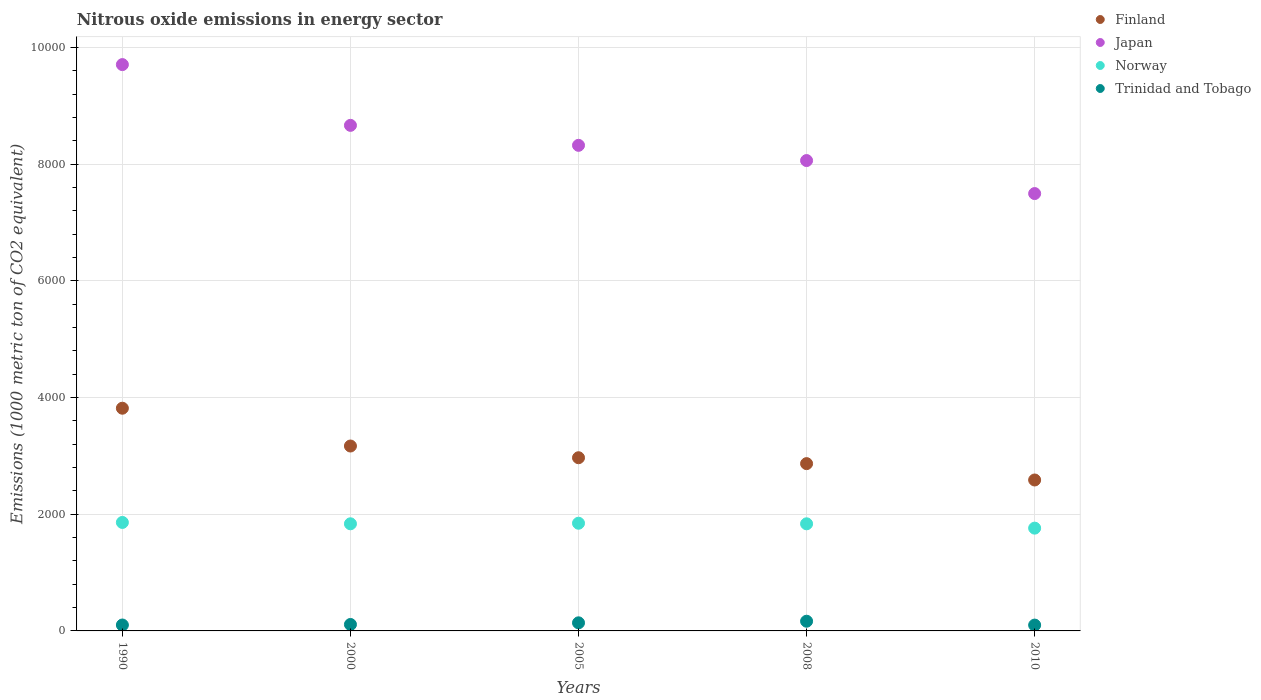Is the number of dotlines equal to the number of legend labels?
Provide a succinct answer. Yes. What is the amount of nitrous oxide emitted in Norway in 2010?
Your answer should be very brief. 1762.1. Across all years, what is the maximum amount of nitrous oxide emitted in Trinidad and Tobago?
Your answer should be compact. 166.3. Across all years, what is the minimum amount of nitrous oxide emitted in Trinidad and Tobago?
Your answer should be very brief. 100.1. In which year was the amount of nitrous oxide emitted in Trinidad and Tobago maximum?
Make the answer very short. 2008. In which year was the amount of nitrous oxide emitted in Trinidad and Tobago minimum?
Provide a short and direct response. 2010. What is the total amount of nitrous oxide emitted in Trinidad and Tobago in the graph?
Your response must be concise. 617. What is the difference between the amount of nitrous oxide emitted in Trinidad and Tobago in 1990 and that in 2010?
Keep it short and to the point. 1.2. What is the difference between the amount of nitrous oxide emitted in Finland in 2000 and the amount of nitrous oxide emitted in Trinidad and Tobago in 2008?
Offer a terse response. 3003.6. What is the average amount of nitrous oxide emitted in Norway per year?
Provide a short and direct response. 1828.16. In the year 2010, what is the difference between the amount of nitrous oxide emitted in Japan and amount of nitrous oxide emitted in Finland?
Give a very brief answer. 4910.3. What is the ratio of the amount of nitrous oxide emitted in Norway in 2005 to that in 2008?
Your answer should be very brief. 1.01. Is the amount of nitrous oxide emitted in Finland in 1990 less than that in 2000?
Your response must be concise. No. What is the difference between the highest and the second highest amount of nitrous oxide emitted in Finland?
Offer a terse response. 648. What is the difference between the highest and the lowest amount of nitrous oxide emitted in Japan?
Keep it short and to the point. 2210.9. In how many years, is the amount of nitrous oxide emitted in Japan greater than the average amount of nitrous oxide emitted in Japan taken over all years?
Your answer should be very brief. 2. Is the sum of the amount of nitrous oxide emitted in Norway in 2000 and 2010 greater than the maximum amount of nitrous oxide emitted in Finland across all years?
Provide a short and direct response. No. Does the amount of nitrous oxide emitted in Finland monotonically increase over the years?
Keep it short and to the point. No. Is the amount of nitrous oxide emitted in Japan strictly greater than the amount of nitrous oxide emitted in Norway over the years?
Keep it short and to the point. Yes. How many dotlines are there?
Your answer should be very brief. 4. What is the difference between two consecutive major ticks on the Y-axis?
Your response must be concise. 2000. Where does the legend appear in the graph?
Make the answer very short. Top right. How many legend labels are there?
Keep it short and to the point. 4. What is the title of the graph?
Give a very brief answer. Nitrous oxide emissions in energy sector. Does "Kazakhstan" appear as one of the legend labels in the graph?
Ensure brevity in your answer.  No. What is the label or title of the X-axis?
Your answer should be compact. Years. What is the label or title of the Y-axis?
Your response must be concise. Emissions (1000 metric ton of CO2 equivalent). What is the Emissions (1000 metric ton of CO2 equivalent) in Finland in 1990?
Offer a very short reply. 3817.9. What is the Emissions (1000 metric ton of CO2 equivalent) in Japan in 1990?
Give a very brief answer. 9708.8. What is the Emissions (1000 metric ton of CO2 equivalent) of Norway in 1990?
Your response must be concise. 1859.7. What is the Emissions (1000 metric ton of CO2 equivalent) of Trinidad and Tobago in 1990?
Provide a succinct answer. 101.3. What is the Emissions (1000 metric ton of CO2 equivalent) in Finland in 2000?
Provide a short and direct response. 3169.9. What is the Emissions (1000 metric ton of CO2 equivalent) of Japan in 2000?
Make the answer very short. 8667.2. What is the Emissions (1000 metric ton of CO2 equivalent) in Norway in 2000?
Offer a terse response. 1836.5. What is the Emissions (1000 metric ton of CO2 equivalent) in Trinidad and Tobago in 2000?
Your answer should be compact. 110.5. What is the Emissions (1000 metric ton of CO2 equivalent) in Finland in 2005?
Offer a terse response. 2969. What is the Emissions (1000 metric ton of CO2 equivalent) in Japan in 2005?
Your answer should be compact. 8324.7. What is the Emissions (1000 metric ton of CO2 equivalent) of Norway in 2005?
Your answer should be very brief. 1846.2. What is the Emissions (1000 metric ton of CO2 equivalent) in Trinidad and Tobago in 2005?
Your answer should be compact. 138.8. What is the Emissions (1000 metric ton of CO2 equivalent) of Finland in 2008?
Provide a succinct answer. 2868. What is the Emissions (1000 metric ton of CO2 equivalent) of Japan in 2008?
Your answer should be compact. 8063.7. What is the Emissions (1000 metric ton of CO2 equivalent) of Norway in 2008?
Give a very brief answer. 1836.3. What is the Emissions (1000 metric ton of CO2 equivalent) of Trinidad and Tobago in 2008?
Make the answer very short. 166.3. What is the Emissions (1000 metric ton of CO2 equivalent) of Finland in 2010?
Make the answer very short. 2587.6. What is the Emissions (1000 metric ton of CO2 equivalent) of Japan in 2010?
Ensure brevity in your answer.  7497.9. What is the Emissions (1000 metric ton of CO2 equivalent) of Norway in 2010?
Provide a short and direct response. 1762.1. What is the Emissions (1000 metric ton of CO2 equivalent) in Trinidad and Tobago in 2010?
Your response must be concise. 100.1. Across all years, what is the maximum Emissions (1000 metric ton of CO2 equivalent) in Finland?
Ensure brevity in your answer.  3817.9. Across all years, what is the maximum Emissions (1000 metric ton of CO2 equivalent) in Japan?
Your response must be concise. 9708.8. Across all years, what is the maximum Emissions (1000 metric ton of CO2 equivalent) in Norway?
Your answer should be very brief. 1859.7. Across all years, what is the maximum Emissions (1000 metric ton of CO2 equivalent) in Trinidad and Tobago?
Offer a very short reply. 166.3. Across all years, what is the minimum Emissions (1000 metric ton of CO2 equivalent) of Finland?
Your answer should be compact. 2587.6. Across all years, what is the minimum Emissions (1000 metric ton of CO2 equivalent) of Japan?
Keep it short and to the point. 7497.9. Across all years, what is the minimum Emissions (1000 metric ton of CO2 equivalent) of Norway?
Give a very brief answer. 1762.1. Across all years, what is the minimum Emissions (1000 metric ton of CO2 equivalent) in Trinidad and Tobago?
Your answer should be very brief. 100.1. What is the total Emissions (1000 metric ton of CO2 equivalent) of Finland in the graph?
Make the answer very short. 1.54e+04. What is the total Emissions (1000 metric ton of CO2 equivalent) in Japan in the graph?
Offer a very short reply. 4.23e+04. What is the total Emissions (1000 metric ton of CO2 equivalent) of Norway in the graph?
Offer a very short reply. 9140.8. What is the total Emissions (1000 metric ton of CO2 equivalent) in Trinidad and Tobago in the graph?
Keep it short and to the point. 617. What is the difference between the Emissions (1000 metric ton of CO2 equivalent) in Finland in 1990 and that in 2000?
Your answer should be very brief. 648. What is the difference between the Emissions (1000 metric ton of CO2 equivalent) of Japan in 1990 and that in 2000?
Make the answer very short. 1041.6. What is the difference between the Emissions (1000 metric ton of CO2 equivalent) of Norway in 1990 and that in 2000?
Your answer should be compact. 23.2. What is the difference between the Emissions (1000 metric ton of CO2 equivalent) in Trinidad and Tobago in 1990 and that in 2000?
Offer a very short reply. -9.2. What is the difference between the Emissions (1000 metric ton of CO2 equivalent) of Finland in 1990 and that in 2005?
Offer a terse response. 848.9. What is the difference between the Emissions (1000 metric ton of CO2 equivalent) of Japan in 1990 and that in 2005?
Offer a very short reply. 1384.1. What is the difference between the Emissions (1000 metric ton of CO2 equivalent) of Norway in 1990 and that in 2005?
Give a very brief answer. 13.5. What is the difference between the Emissions (1000 metric ton of CO2 equivalent) in Trinidad and Tobago in 1990 and that in 2005?
Your response must be concise. -37.5. What is the difference between the Emissions (1000 metric ton of CO2 equivalent) of Finland in 1990 and that in 2008?
Keep it short and to the point. 949.9. What is the difference between the Emissions (1000 metric ton of CO2 equivalent) in Japan in 1990 and that in 2008?
Ensure brevity in your answer.  1645.1. What is the difference between the Emissions (1000 metric ton of CO2 equivalent) in Norway in 1990 and that in 2008?
Keep it short and to the point. 23.4. What is the difference between the Emissions (1000 metric ton of CO2 equivalent) of Trinidad and Tobago in 1990 and that in 2008?
Your answer should be very brief. -65. What is the difference between the Emissions (1000 metric ton of CO2 equivalent) in Finland in 1990 and that in 2010?
Make the answer very short. 1230.3. What is the difference between the Emissions (1000 metric ton of CO2 equivalent) of Japan in 1990 and that in 2010?
Your answer should be compact. 2210.9. What is the difference between the Emissions (1000 metric ton of CO2 equivalent) in Norway in 1990 and that in 2010?
Give a very brief answer. 97.6. What is the difference between the Emissions (1000 metric ton of CO2 equivalent) in Trinidad and Tobago in 1990 and that in 2010?
Give a very brief answer. 1.2. What is the difference between the Emissions (1000 metric ton of CO2 equivalent) of Finland in 2000 and that in 2005?
Offer a terse response. 200.9. What is the difference between the Emissions (1000 metric ton of CO2 equivalent) of Japan in 2000 and that in 2005?
Make the answer very short. 342.5. What is the difference between the Emissions (1000 metric ton of CO2 equivalent) in Norway in 2000 and that in 2005?
Ensure brevity in your answer.  -9.7. What is the difference between the Emissions (1000 metric ton of CO2 equivalent) in Trinidad and Tobago in 2000 and that in 2005?
Your answer should be compact. -28.3. What is the difference between the Emissions (1000 metric ton of CO2 equivalent) in Finland in 2000 and that in 2008?
Offer a terse response. 301.9. What is the difference between the Emissions (1000 metric ton of CO2 equivalent) of Japan in 2000 and that in 2008?
Your answer should be very brief. 603.5. What is the difference between the Emissions (1000 metric ton of CO2 equivalent) of Norway in 2000 and that in 2008?
Ensure brevity in your answer.  0.2. What is the difference between the Emissions (1000 metric ton of CO2 equivalent) in Trinidad and Tobago in 2000 and that in 2008?
Ensure brevity in your answer.  -55.8. What is the difference between the Emissions (1000 metric ton of CO2 equivalent) of Finland in 2000 and that in 2010?
Provide a succinct answer. 582.3. What is the difference between the Emissions (1000 metric ton of CO2 equivalent) of Japan in 2000 and that in 2010?
Make the answer very short. 1169.3. What is the difference between the Emissions (1000 metric ton of CO2 equivalent) in Norway in 2000 and that in 2010?
Offer a terse response. 74.4. What is the difference between the Emissions (1000 metric ton of CO2 equivalent) in Finland in 2005 and that in 2008?
Give a very brief answer. 101. What is the difference between the Emissions (1000 metric ton of CO2 equivalent) of Japan in 2005 and that in 2008?
Give a very brief answer. 261. What is the difference between the Emissions (1000 metric ton of CO2 equivalent) in Norway in 2005 and that in 2008?
Your answer should be very brief. 9.9. What is the difference between the Emissions (1000 metric ton of CO2 equivalent) in Trinidad and Tobago in 2005 and that in 2008?
Your answer should be very brief. -27.5. What is the difference between the Emissions (1000 metric ton of CO2 equivalent) in Finland in 2005 and that in 2010?
Your response must be concise. 381.4. What is the difference between the Emissions (1000 metric ton of CO2 equivalent) in Japan in 2005 and that in 2010?
Keep it short and to the point. 826.8. What is the difference between the Emissions (1000 metric ton of CO2 equivalent) of Norway in 2005 and that in 2010?
Provide a short and direct response. 84.1. What is the difference between the Emissions (1000 metric ton of CO2 equivalent) in Trinidad and Tobago in 2005 and that in 2010?
Your answer should be compact. 38.7. What is the difference between the Emissions (1000 metric ton of CO2 equivalent) in Finland in 2008 and that in 2010?
Your answer should be very brief. 280.4. What is the difference between the Emissions (1000 metric ton of CO2 equivalent) in Japan in 2008 and that in 2010?
Your response must be concise. 565.8. What is the difference between the Emissions (1000 metric ton of CO2 equivalent) in Norway in 2008 and that in 2010?
Keep it short and to the point. 74.2. What is the difference between the Emissions (1000 metric ton of CO2 equivalent) in Trinidad and Tobago in 2008 and that in 2010?
Offer a very short reply. 66.2. What is the difference between the Emissions (1000 metric ton of CO2 equivalent) of Finland in 1990 and the Emissions (1000 metric ton of CO2 equivalent) of Japan in 2000?
Offer a terse response. -4849.3. What is the difference between the Emissions (1000 metric ton of CO2 equivalent) in Finland in 1990 and the Emissions (1000 metric ton of CO2 equivalent) in Norway in 2000?
Provide a succinct answer. 1981.4. What is the difference between the Emissions (1000 metric ton of CO2 equivalent) of Finland in 1990 and the Emissions (1000 metric ton of CO2 equivalent) of Trinidad and Tobago in 2000?
Ensure brevity in your answer.  3707.4. What is the difference between the Emissions (1000 metric ton of CO2 equivalent) of Japan in 1990 and the Emissions (1000 metric ton of CO2 equivalent) of Norway in 2000?
Offer a very short reply. 7872.3. What is the difference between the Emissions (1000 metric ton of CO2 equivalent) in Japan in 1990 and the Emissions (1000 metric ton of CO2 equivalent) in Trinidad and Tobago in 2000?
Ensure brevity in your answer.  9598.3. What is the difference between the Emissions (1000 metric ton of CO2 equivalent) in Norway in 1990 and the Emissions (1000 metric ton of CO2 equivalent) in Trinidad and Tobago in 2000?
Ensure brevity in your answer.  1749.2. What is the difference between the Emissions (1000 metric ton of CO2 equivalent) in Finland in 1990 and the Emissions (1000 metric ton of CO2 equivalent) in Japan in 2005?
Your answer should be very brief. -4506.8. What is the difference between the Emissions (1000 metric ton of CO2 equivalent) in Finland in 1990 and the Emissions (1000 metric ton of CO2 equivalent) in Norway in 2005?
Provide a short and direct response. 1971.7. What is the difference between the Emissions (1000 metric ton of CO2 equivalent) of Finland in 1990 and the Emissions (1000 metric ton of CO2 equivalent) of Trinidad and Tobago in 2005?
Your response must be concise. 3679.1. What is the difference between the Emissions (1000 metric ton of CO2 equivalent) of Japan in 1990 and the Emissions (1000 metric ton of CO2 equivalent) of Norway in 2005?
Your answer should be compact. 7862.6. What is the difference between the Emissions (1000 metric ton of CO2 equivalent) of Japan in 1990 and the Emissions (1000 metric ton of CO2 equivalent) of Trinidad and Tobago in 2005?
Keep it short and to the point. 9570. What is the difference between the Emissions (1000 metric ton of CO2 equivalent) of Norway in 1990 and the Emissions (1000 metric ton of CO2 equivalent) of Trinidad and Tobago in 2005?
Ensure brevity in your answer.  1720.9. What is the difference between the Emissions (1000 metric ton of CO2 equivalent) in Finland in 1990 and the Emissions (1000 metric ton of CO2 equivalent) in Japan in 2008?
Your answer should be very brief. -4245.8. What is the difference between the Emissions (1000 metric ton of CO2 equivalent) in Finland in 1990 and the Emissions (1000 metric ton of CO2 equivalent) in Norway in 2008?
Provide a succinct answer. 1981.6. What is the difference between the Emissions (1000 metric ton of CO2 equivalent) in Finland in 1990 and the Emissions (1000 metric ton of CO2 equivalent) in Trinidad and Tobago in 2008?
Ensure brevity in your answer.  3651.6. What is the difference between the Emissions (1000 metric ton of CO2 equivalent) in Japan in 1990 and the Emissions (1000 metric ton of CO2 equivalent) in Norway in 2008?
Your answer should be very brief. 7872.5. What is the difference between the Emissions (1000 metric ton of CO2 equivalent) of Japan in 1990 and the Emissions (1000 metric ton of CO2 equivalent) of Trinidad and Tobago in 2008?
Your response must be concise. 9542.5. What is the difference between the Emissions (1000 metric ton of CO2 equivalent) of Norway in 1990 and the Emissions (1000 metric ton of CO2 equivalent) of Trinidad and Tobago in 2008?
Your answer should be very brief. 1693.4. What is the difference between the Emissions (1000 metric ton of CO2 equivalent) in Finland in 1990 and the Emissions (1000 metric ton of CO2 equivalent) in Japan in 2010?
Ensure brevity in your answer.  -3680. What is the difference between the Emissions (1000 metric ton of CO2 equivalent) of Finland in 1990 and the Emissions (1000 metric ton of CO2 equivalent) of Norway in 2010?
Ensure brevity in your answer.  2055.8. What is the difference between the Emissions (1000 metric ton of CO2 equivalent) of Finland in 1990 and the Emissions (1000 metric ton of CO2 equivalent) of Trinidad and Tobago in 2010?
Offer a terse response. 3717.8. What is the difference between the Emissions (1000 metric ton of CO2 equivalent) of Japan in 1990 and the Emissions (1000 metric ton of CO2 equivalent) of Norway in 2010?
Your answer should be very brief. 7946.7. What is the difference between the Emissions (1000 metric ton of CO2 equivalent) in Japan in 1990 and the Emissions (1000 metric ton of CO2 equivalent) in Trinidad and Tobago in 2010?
Your answer should be compact. 9608.7. What is the difference between the Emissions (1000 metric ton of CO2 equivalent) of Norway in 1990 and the Emissions (1000 metric ton of CO2 equivalent) of Trinidad and Tobago in 2010?
Provide a succinct answer. 1759.6. What is the difference between the Emissions (1000 metric ton of CO2 equivalent) in Finland in 2000 and the Emissions (1000 metric ton of CO2 equivalent) in Japan in 2005?
Your answer should be very brief. -5154.8. What is the difference between the Emissions (1000 metric ton of CO2 equivalent) of Finland in 2000 and the Emissions (1000 metric ton of CO2 equivalent) of Norway in 2005?
Give a very brief answer. 1323.7. What is the difference between the Emissions (1000 metric ton of CO2 equivalent) in Finland in 2000 and the Emissions (1000 metric ton of CO2 equivalent) in Trinidad and Tobago in 2005?
Make the answer very short. 3031.1. What is the difference between the Emissions (1000 metric ton of CO2 equivalent) in Japan in 2000 and the Emissions (1000 metric ton of CO2 equivalent) in Norway in 2005?
Give a very brief answer. 6821. What is the difference between the Emissions (1000 metric ton of CO2 equivalent) of Japan in 2000 and the Emissions (1000 metric ton of CO2 equivalent) of Trinidad and Tobago in 2005?
Your answer should be very brief. 8528.4. What is the difference between the Emissions (1000 metric ton of CO2 equivalent) in Norway in 2000 and the Emissions (1000 metric ton of CO2 equivalent) in Trinidad and Tobago in 2005?
Give a very brief answer. 1697.7. What is the difference between the Emissions (1000 metric ton of CO2 equivalent) in Finland in 2000 and the Emissions (1000 metric ton of CO2 equivalent) in Japan in 2008?
Provide a succinct answer. -4893.8. What is the difference between the Emissions (1000 metric ton of CO2 equivalent) of Finland in 2000 and the Emissions (1000 metric ton of CO2 equivalent) of Norway in 2008?
Your response must be concise. 1333.6. What is the difference between the Emissions (1000 metric ton of CO2 equivalent) of Finland in 2000 and the Emissions (1000 metric ton of CO2 equivalent) of Trinidad and Tobago in 2008?
Give a very brief answer. 3003.6. What is the difference between the Emissions (1000 metric ton of CO2 equivalent) in Japan in 2000 and the Emissions (1000 metric ton of CO2 equivalent) in Norway in 2008?
Make the answer very short. 6830.9. What is the difference between the Emissions (1000 metric ton of CO2 equivalent) in Japan in 2000 and the Emissions (1000 metric ton of CO2 equivalent) in Trinidad and Tobago in 2008?
Provide a short and direct response. 8500.9. What is the difference between the Emissions (1000 metric ton of CO2 equivalent) of Norway in 2000 and the Emissions (1000 metric ton of CO2 equivalent) of Trinidad and Tobago in 2008?
Provide a short and direct response. 1670.2. What is the difference between the Emissions (1000 metric ton of CO2 equivalent) of Finland in 2000 and the Emissions (1000 metric ton of CO2 equivalent) of Japan in 2010?
Offer a terse response. -4328. What is the difference between the Emissions (1000 metric ton of CO2 equivalent) in Finland in 2000 and the Emissions (1000 metric ton of CO2 equivalent) in Norway in 2010?
Make the answer very short. 1407.8. What is the difference between the Emissions (1000 metric ton of CO2 equivalent) in Finland in 2000 and the Emissions (1000 metric ton of CO2 equivalent) in Trinidad and Tobago in 2010?
Offer a very short reply. 3069.8. What is the difference between the Emissions (1000 metric ton of CO2 equivalent) of Japan in 2000 and the Emissions (1000 metric ton of CO2 equivalent) of Norway in 2010?
Make the answer very short. 6905.1. What is the difference between the Emissions (1000 metric ton of CO2 equivalent) in Japan in 2000 and the Emissions (1000 metric ton of CO2 equivalent) in Trinidad and Tobago in 2010?
Provide a succinct answer. 8567.1. What is the difference between the Emissions (1000 metric ton of CO2 equivalent) of Norway in 2000 and the Emissions (1000 metric ton of CO2 equivalent) of Trinidad and Tobago in 2010?
Offer a very short reply. 1736.4. What is the difference between the Emissions (1000 metric ton of CO2 equivalent) of Finland in 2005 and the Emissions (1000 metric ton of CO2 equivalent) of Japan in 2008?
Offer a terse response. -5094.7. What is the difference between the Emissions (1000 metric ton of CO2 equivalent) in Finland in 2005 and the Emissions (1000 metric ton of CO2 equivalent) in Norway in 2008?
Make the answer very short. 1132.7. What is the difference between the Emissions (1000 metric ton of CO2 equivalent) of Finland in 2005 and the Emissions (1000 metric ton of CO2 equivalent) of Trinidad and Tobago in 2008?
Make the answer very short. 2802.7. What is the difference between the Emissions (1000 metric ton of CO2 equivalent) in Japan in 2005 and the Emissions (1000 metric ton of CO2 equivalent) in Norway in 2008?
Ensure brevity in your answer.  6488.4. What is the difference between the Emissions (1000 metric ton of CO2 equivalent) in Japan in 2005 and the Emissions (1000 metric ton of CO2 equivalent) in Trinidad and Tobago in 2008?
Provide a short and direct response. 8158.4. What is the difference between the Emissions (1000 metric ton of CO2 equivalent) in Norway in 2005 and the Emissions (1000 metric ton of CO2 equivalent) in Trinidad and Tobago in 2008?
Give a very brief answer. 1679.9. What is the difference between the Emissions (1000 metric ton of CO2 equivalent) in Finland in 2005 and the Emissions (1000 metric ton of CO2 equivalent) in Japan in 2010?
Make the answer very short. -4528.9. What is the difference between the Emissions (1000 metric ton of CO2 equivalent) in Finland in 2005 and the Emissions (1000 metric ton of CO2 equivalent) in Norway in 2010?
Provide a short and direct response. 1206.9. What is the difference between the Emissions (1000 metric ton of CO2 equivalent) of Finland in 2005 and the Emissions (1000 metric ton of CO2 equivalent) of Trinidad and Tobago in 2010?
Ensure brevity in your answer.  2868.9. What is the difference between the Emissions (1000 metric ton of CO2 equivalent) of Japan in 2005 and the Emissions (1000 metric ton of CO2 equivalent) of Norway in 2010?
Keep it short and to the point. 6562.6. What is the difference between the Emissions (1000 metric ton of CO2 equivalent) in Japan in 2005 and the Emissions (1000 metric ton of CO2 equivalent) in Trinidad and Tobago in 2010?
Provide a succinct answer. 8224.6. What is the difference between the Emissions (1000 metric ton of CO2 equivalent) in Norway in 2005 and the Emissions (1000 metric ton of CO2 equivalent) in Trinidad and Tobago in 2010?
Make the answer very short. 1746.1. What is the difference between the Emissions (1000 metric ton of CO2 equivalent) in Finland in 2008 and the Emissions (1000 metric ton of CO2 equivalent) in Japan in 2010?
Give a very brief answer. -4629.9. What is the difference between the Emissions (1000 metric ton of CO2 equivalent) of Finland in 2008 and the Emissions (1000 metric ton of CO2 equivalent) of Norway in 2010?
Your answer should be compact. 1105.9. What is the difference between the Emissions (1000 metric ton of CO2 equivalent) of Finland in 2008 and the Emissions (1000 metric ton of CO2 equivalent) of Trinidad and Tobago in 2010?
Offer a terse response. 2767.9. What is the difference between the Emissions (1000 metric ton of CO2 equivalent) of Japan in 2008 and the Emissions (1000 metric ton of CO2 equivalent) of Norway in 2010?
Make the answer very short. 6301.6. What is the difference between the Emissions (1000 metric ton of CO2 equivalent) of Japan in 2008 and the Emissions (1000 metric ton of CO2 equivalent) of Trinidad and Tobago in 2010?
Give a very brief answer. 7963.6. What is the difference between the Emissions (1000 metric ton of CO2 equivalent) in Norway in 2008 and the Emissions (1000 metric ton of CO2 equivalent) in Trinidad and Tobago in 2010?
Ensure brevity in your answer.  1736.2. What is the average Emissions (1000 metric ton of CO2 equivalent) of Finland per year?
Your answer should be compact. 3082.48. What is the average Emissions (1000 metric ton of CO2 equivalent) in Japan per year?
Keep it short and to the point. 8452.46. What is the average Emissions (1000 metric ton of CO2 equivalent) of Norway per year?
Your answer should be compact. 1828.16. What is the average Emissions (1000 metric ton of CO2 equivalent) of Trinidad and Tobago per year?
Your answer should be compact. 123.4. In the year 1990, what is the difference between the Emissions (1000 metric ton of CO2 equivalent) of Finland and Emissions (1000 metric ton of CO2 equivalent) of Japan?
Provide a short and direct response. -5890.9. In the year 1990, what is the difference between the Emissions (1000 metric ton of CO2 equivalent) of Finland and Emissions (1000 metric ton of CO2 equivalent) of Norway?
Keep it short and to the point. 1958.2. In the year 1990, what is the difference between the Emissions (1000 metric ton of CO2 equivalent) of Finland and Emissions (1000 metric ton of CO2 equivalent) of Trinidad and Tobago?
Ensure brevity in your answer.  3716.6. In the year 1990, what is the difference between the Emissions (1000 metric ton of CO2 equivalent) in Japan and Emissions (1000 metric ton of CO2 equivalent) in Norway?
Keep it short and to the point. 7849.1. In the year 1990, what is the difference between the Emissions (1000 metric ton of CO2 equivalent) of Japan and Emissions (1000 metric ton of CO2 equivalent) of Trinidad and Tobago?
Ensure brevity in your answer.  9607.5. In the year 1990, what is the difference between the Emissions (1000 metric ton of CO2 equivalent) in Norway and Emissions (1000 metric ton of CO2 equivalent) in Trinidad and Tobago?
Give a very brief answer. 1758.4. In the year 2000, what is the difference between the Emissions (1000 metric ton of CO2 equivalent) of Finland and Emissions (1000 metric ton of CO2 equivalent) of Japan?
Your response must be concise. -5497.3. In the year 2000, what is the difference between the Emissions (1000 metric ton of CO2 equivalent) in Finland and Emissions (1000 metric ton of CO2 equivalent) in Norway?
Ensure brevity in your answer.  1333.4. In the year 2000, what is the difference between the Emissions (1000 metric ton of CO2 equivalent) of Finland and Emissions (1000 metric ton of CO2 equivalent) of Trinidad and Tobago?
Keep it short and to the point. 3059.4. In the year 2000, what is the difference between the Emissions (1000 metric ton of CO2 equivalent) of Japan and Emissions (1000 metric ton of CO2 equivalent) of Norway?
Your response must be concise. 6830.7. In the year 2000, what is the difference between the Emissions (1000 metric ton of CO2 equivalent) in Japan and Emissions (1000 metric ton of CO2 equivalent) in Trinidad and Tobago?
Your answer should be compact. 8556.7. In the year 2000, what is the difference between the Emissions (1000 metric ton of CO2 equivalent) in Norway and Emissions (1000 metric ton of CO2 equivalent) in Trinidad and Tobago?
Ensure brevity in your answer.  1726. In the year 2005, what is the difference between the Emissions (1000 metric ton of CO2 equivalent) in Finland and Emissions (1000 metric ton of CO2 equivalent) in Japan?
Offer a terse response. -5355.7. In the year 2005, what is the difference between the Emissions (1000 metric ton of CO2 equivalent) in Finland and Emissions (1000 metric ton of CO2 equivalent) in Norway?
Provide a short and direct response. 1122.8. In the year 2005, what is the difference between the Emissions (1000 metric ton of CO2 equivalent) of Finland and Emissions (1000 metric ton of CO2 equivalent) of Trinidad and Tobago?
Give a very brief answer. 2830.2. In the year 2005, what is the difference between the Emissions (1000 metric ton of CO2 equivalent) in Japan and Emissions (1000 metric ton of CO2 equivalent) in Norway?
Your answer should be compact. 6478.5. In the year 2005, what is the difference between the Emissions (1000 metric ton of CO2 equivalent) of Japan and Emissions (1000 metric ton of CO2 equivalent) of Trinidad and Tobago?
Your answer should be compact. 8185.9. In the year 2005, what is the difference between the Emissions (1000 metric ton of CO2 equivalent) in Norway and Emissions (1000 metric ton of CO2 equivalent) in Trinidad and Tobago?
Your answer should be very brief. 1707.4. In the year 2008, what is the difference between the Emissions (1000 metric ton of CO2 equivalent) of Finland and Emissions (1000 metric ton of CO2 equivalent) of Japan?
Your response must be concise. -5195.7. In the year 2008, what is the difference between the Emissions (1000 metric ton of CO2 equivalent) of Finland and Emissions (1000 metric ton of CO2 equivalent) of Norway?
Your answer should be very brief. 1031.7. In the year 2008, what is the difference between the Emissions (1000 metric ton of CO2 equivalent) in Finland and Emissions (1000 metric ton of CO2 equivalent) in Trinidad and Tobago?
Ensure brevity in your answer.  2701.7. In the year 2008, what is the difference between the Emissions (1000 metric ton of CO2 equivalent) of Japan and Emissions (1000 metric ton of CO2 equivalent) of Norway?
Offer a terse response. 6227.4. In the year 2008, what is the difference between the Emissions (1000 metric ton of CO2 equivalent) in Japan and Emissions (1000 metric ton of CO2 equivalent) in Trinidad and Tobago?
Make the answer very short. 7897.4. In the year 2008, what is the difference between the Emissions (1000 metric ton of CO2 equivalent) of Norway and Emissions (1000 metric ton of CO2 equivalent) of Trinidad and Tobago?
Provide a short and direct response. 1670. In the year 2010, what is the difference between the Emissions (1000 metric ton of CO2 equivalent) in Finland and Emissions (1000 metric ton of CO2 equivalent) in Japan?
Offer a terse response. -4910.3. In the year 2010, what is the difference between the Emissions (1000 metric ton of CO2 equivalent) of Finland and Emissions (1000 metric ton of CO2 equivalent) of Norway?
Provide a succinct answer. 825.5. In the year 2010, what is the difference between the Emissions (1000 metric ton of CO2 equivalent) in Finland and Emissions (1000 metric ton of CO2 equivalent) in Trinidad and Tobago?
Give a very brief answer. 2487.5. In the year 2010, what is the difference between the Emissions (1000 metric ton of CO2 equivalent) of Japan and Emissions (1000 metric ton of CO2 equivalent) of Norway?
Your response must be concise. 5735.8. In the year 2010, what is the difference between the Emissions (1000 metric ton of CO2 equivalent) in Japan and Emissions (1000 metric ton of CO2 equivalent) in Trinidad and Tobago?
Your answer should be compact. 7397.8. In the year 2010, what is the difference between the Emissions (1000 metric ton of CO2 equivalent) in Norway and Emissions (1000 metric ton of CO2 equivalent) in Trinidad and Tobago?
Your answer should be compact. 1662. What is the ratio of the Emissions (1000 metric ton of CO2 equivalent) in Finland in 1990 to that in 2000?
Ensure brevity in your answer.  1.2. What is the ratio of the Emissions (1000 metric ton of CO2 equivalent) of Japan in 1990 to that in 2000?
Ensure brevity in your answer.  1.12. What is the ratio of the Emissions (1000 metric ton of CO2 equivalent) in Norway in 1990 to that in 2000?
Give a very brief answer. 1.01. What is the ratio of the Emissions (1000 metric ton of CO2 equivalent) in Finland in 1990 to that in 2005?
Provide a short and direct response. 1.29. What is the ratio of the Emissions (1000 metric ton of CO2 equivalent) of Japan in 1990 to that in 2005?
Give a very brief answer. 1.17. What is the ratio of the Emissions (1000 metric ton of CO2 equivalent) of Norway in 1990 to that in 2005?
Offer a very short reply. 1.01. What is the ratio of the Emissions (1000 metric ton of CO2 equivalent) in Trinidad and Tobago in 1990 to that in 2005?
Offer a very short reply. 0.73. What is the ratio of the Emissions (1000 metric ton of CO2 equivalent) of Finland in 1990 to that in 2008?
Make the answer very short. 1.33. What is the ratio of the Emissions (1000 metric ton of CO2 equivalent) in Japan in 1990 to that in 2008?
Keep it short and to the point. 1.2. What is the ratio of the Emissions (1000 metric ton of CO2 equivalent) in Norway in 1990 to that in 2008?
Offer a very short reply. 1.01. What is the ratio of the Emissions (1000 metric ton of CO2 equivalent) of Trinidad and Tobago in 1990 to that in 2008?
Your answer should be very brief. 0.61. What is the ratio of the Emissions (1000 metric ton of CO2 equivalent) in Finland in 1990 to that in 2010?
Your answer should be very brief. 1.48. What is the ratio of the Emissions (1000 metric ton of CO2 equivalent) of Japan in 1990 to that in 2010?
Make the answer very short. 1.29. What is the ratio of the Emissions (1000 metric ton of CO2 equivalent) in Norway in 1990 to that in 2010?
Your answer should be compact. 1.06. What is the ratio of the Emissions (1000 metric ton of CO2 equivalent) of Finland in 2000 to that in 2005?
Ensure brevity in your answer.  1.07. What is the ratio of the Emissions (1000 metric ton of CO2 equivalent) of Japan in 2000 to that in 2005?
Your answer should be very brief. 1.04. What is the ratio of the Emissions (1000 metric ton of CO2 equivalent) in Norway in 2000 to that in 2005?
Ensure brevity in your answer.  0.99. What is the ratio of the Emissions (1000 metric ton of CO2 equivalent) in Trinidad and Tobago in 2000 to that in 2005?
Provide a short and direct response. 0.8. What is the ratio of the Emissions (1000 metric ton of CO2 equivalent) in Finland in 2000 to that in 2008?
Your answer should be very brief. 1.11. What is the ratio of the Emissions (1000 metric ton of CO2 equivalent) in Japan in 2000 to that in 2008?
Your response must be concise. 1.07. What is the ratio of the Emissions (1000 metric ton of CO2 equivalent) in Norway in 2000 to that in 2008?
Your answer should be very brief. 1. What is the ratio of the Emissions (1000 metric ton of CO2 equivalent) of Trinidad and Tobago in 2000 to that in 2008?
Keep it short and to the point. 0.66. What is the ratio of the Emissions (1000 metric ton of CO2 equivalent) in Finland in 2000 to that in 2010?
Your answer should be compact. 1.23. What is the ratio of the Emissions (1000 metric ton of CO2 equivalent) of Japan in 2000 to that in 2010?
Provide a succinct answer. 1.16. What is the ratio of the Emissions (1000 metric ton of CO2 equivalent) in Norway in 2000 to that in 2010?
Your response must be concise. 1.04. What is the ratio of the Emissions (1000 metric ton of CO2 equivalent) of Trinidad and Tobago in 2000 to that in 2010?
Your answer should be compact. 1.1. What is the ratio of the Emissions (1000 metric ton of CO2 equivalent) of Finland in 2005 to that in 2008?
Offer a very short reply. 1.04. What is the ratio of the Emissions (1000 metric ton of CO2 equivalent) of Japan in 2005 to that in 2008?
Ensure brevity in your answer.  1.03. What is the ratio of the Emissions (1000 metric ton of CO2 equivalent) of Norway in 2005 to that in 2008?
Offer a terse response. 1.01. What is the ratio of the Emissions (1000 metric ton of CO2 equivalent) of Trinidad and Tobago in 2005 to that in 2008?
Keep it short and to the point. 0.83. What is the ratio of the Emissions (1000 metric ton of CO2 equivalent) in Finland in 2005 to that in 2010?
Provide a succinct answer. 1.15. What is the ratio of the Emissions (1000 metric ton of CO2 equivalent) in Japan in 2005 to that in 2010?
Your answer should be very brief. 1.11. What is the ratio of the Emissions (1000 metric ton of CO2 equivalent) of Norway in 2005 to that in 2010?
Ensure brevity in your answer.  1.05. What is the ratio of the Emissions (1000 metric ton of CO2 equivalent) of Trinidad and Tobago in 2005 to that in 2010?
Make the answer very short. 1.39. What is the ratio of the Emissions (1000 metric ton of CO2 equivalent) of Finland in 2008 to that in 2010?
Keep it short and to the point. 1.11. What is the ratio of the Emissions (1000 metric ton of CO2 equivalent) in Japan in 2008 to that in 2010?
Your answer should be very brief. 1.08. What is the ratio of the Emissions (1000 metric ton of CO2 equivalent) in Norway in 2008 to that in 2010?
Your answer should be very brief. 1.04. What is the ratio of the Emissions (1000 metric ton of CO2 equivalent) of Trinidad and Tobago in 2008 to that in 2010?
Your answer should be compact. 1.66. What is the difference between the highest and the second highest Emissions (1000 metric ton of CO2 equivalent) in Finland?
Keep it short and to the point. 648. What is the difference between the highest and the second highest Emissions (1000 metric ton of CO2 equivalent) of Japan?
Provide a succinct answer. 1041.6. What is the difference between the highest and the second highest Emissions (1000 metric ton of CO2 equivalent) of Norway?
Keep it short and to the point. 13.5. What is the difference between the highest and the lowest Emissions (1000 metric ton of CO2 equivalent) of Finland?
Provide a succinct answer. 1230.3. What is the difference between the highest and the lowest Emissions (1000 metric ton of CO2 equivalent) of Japan?
Your answer should be compact. 2210.9. What is the difference between the highest and the lowest Emissions (1000 metric ton of CO2 equivalent) in Norway?
Ensure brevity in your answer.  97.6. What is the difference between the highest and the lowest Emissions (1000 metric ton of CO2 equivalent) in Trinidad and Tobago?
Your response must be concise. 66.2. 